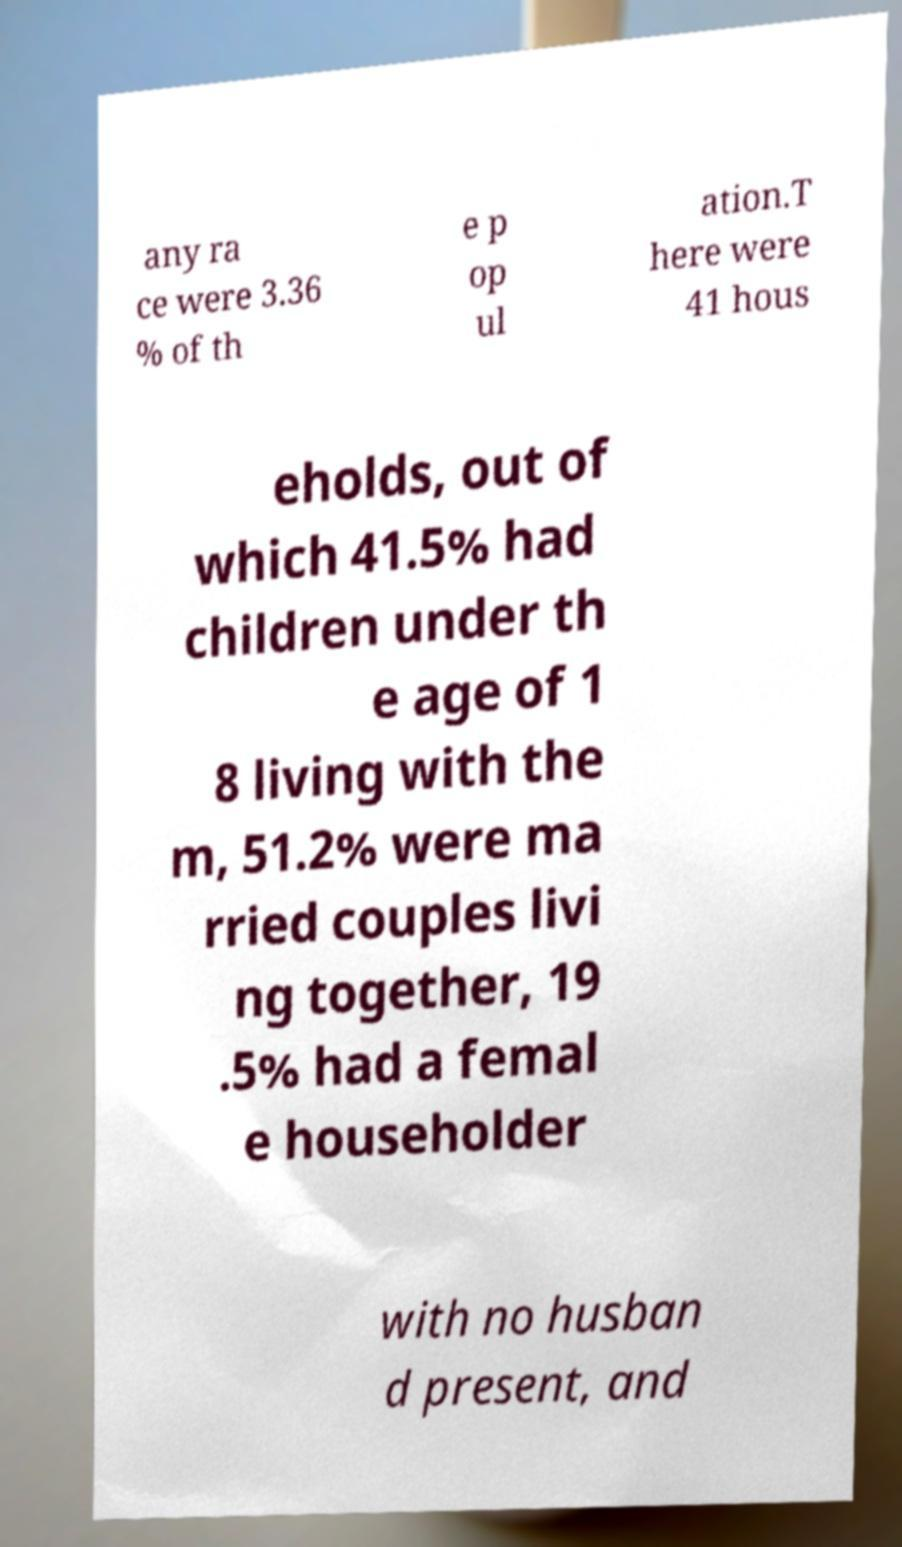There's text embedded in this image that I need extracted. Can you transcribe it verbatim? any ra ce were 3.36 % of th e p op ul ation.T here were 41 hous eholds, out of which 41.5% had children under th e age of 1 8 living with the m, 51.2% were ma rried couples livi ng together, 19 .5% had a femal e householder with no husban d present, and 